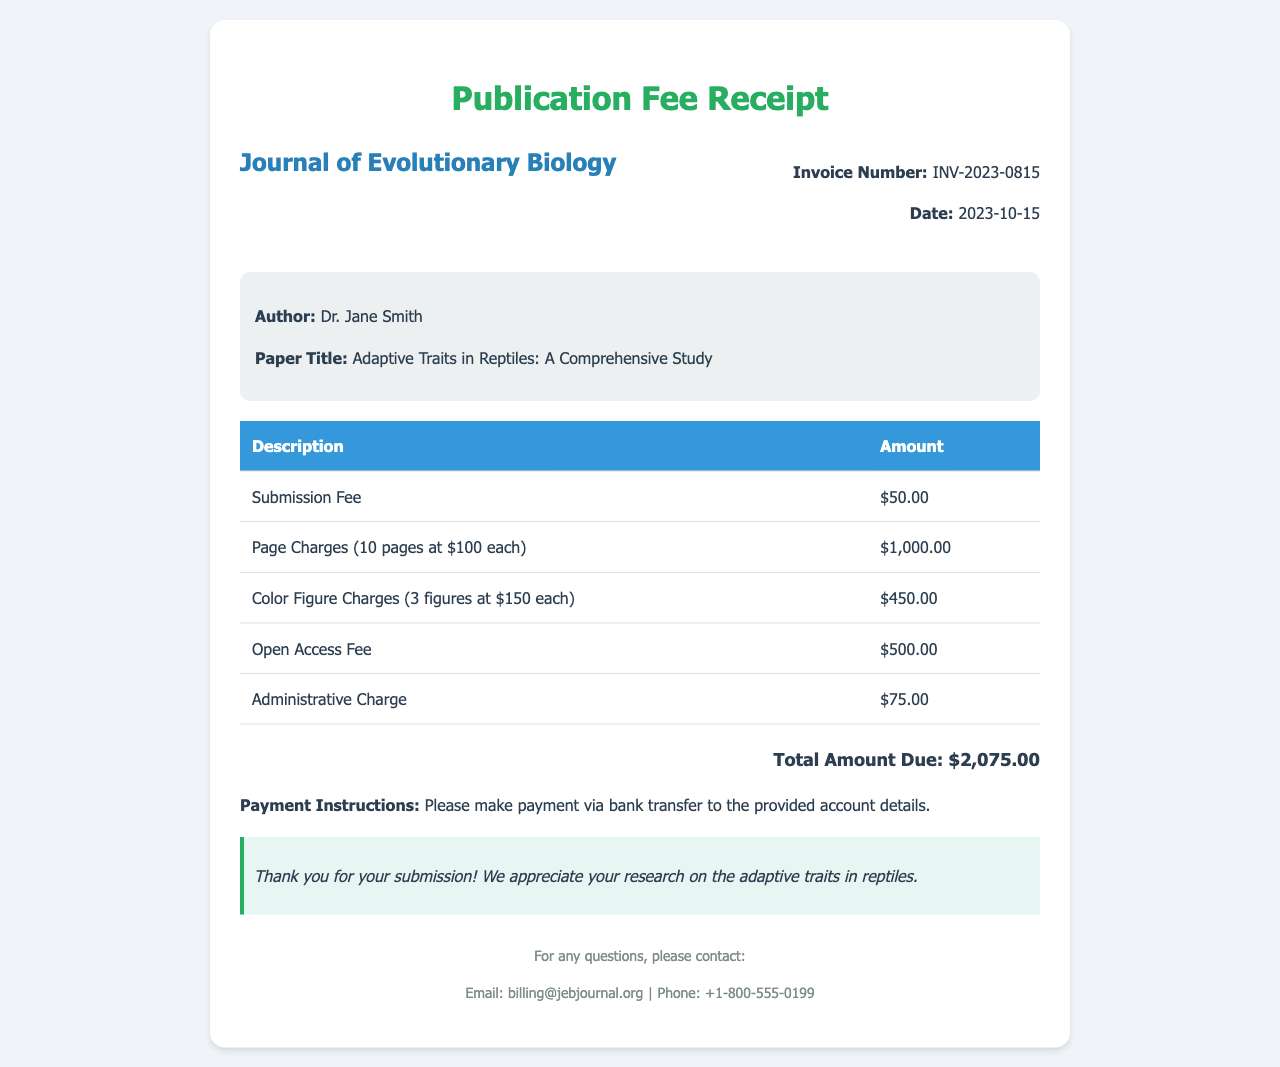What is the invoice number? The invoice number is listed clearly in the document under invoice details.
Answer: INV-2023-0815 What is the date of the invoice? The date is provided alongside the invoice number in the document.
Answer: 2023-10-15 Who is the author of the paper? The author's name is mentioned in the paper information section of the document.
Answer: Dr. Jane Smith What is the title of the research paper? The title is displayed in the paper information section below the author’s name.
Answer: Adaptive Traits in Reptiles: A Comprehensive Study How much is the total amount due? The total amount is summarized at the bottom of the charge breakdown in the document.
Answer: $2,075.00 How much are the page charges? The page charges are detailed with a specific amount in the breakdown section of the document.
Answer: $1,000.00 What is the charge for color figures? The document specifies the charge for color figures in the breakdown section.
Answer: $450.00 What is the amount for the open access fee? The open access fee is listed under the breakdown table in the document.
Answer: $500.00 What payment method is suggested for the publication fee? The document clearly states the payment instructions provided in the receipt.
Answer: Bank transfer 